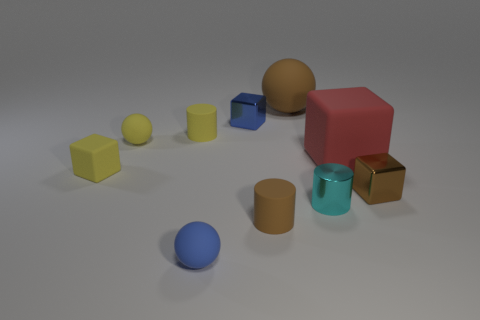Subtract all tiny yellow matte cylinders. How many cylinders are left? 2 Subtract all red blocks. How many blocks are left? 3 Add 6 large spheres. How many large spheres are left? 7 Add 8 tiny purple cubes. How many tiny purple cubes exist? 8 Subtract 0 gray balls. How many objects are left? 10 Subtract all spheres. How many objects are left? 7 Subtract all gray blocks. Subtract all blue spheres. How many blocks are left? 4 Subtract all large brown matte objects. Subtract all yellow matte cubes. How many objects are left? 8 